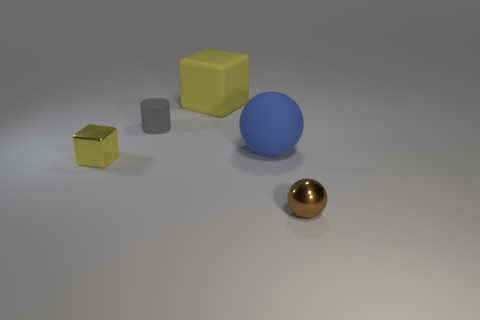Can you describe the colors of the objects in the image? Certainly, the image showcases four objects with distinct colors: a golden sphere, a large blue sphere, a yellow cube, and a smaller, metallic gray cube. 